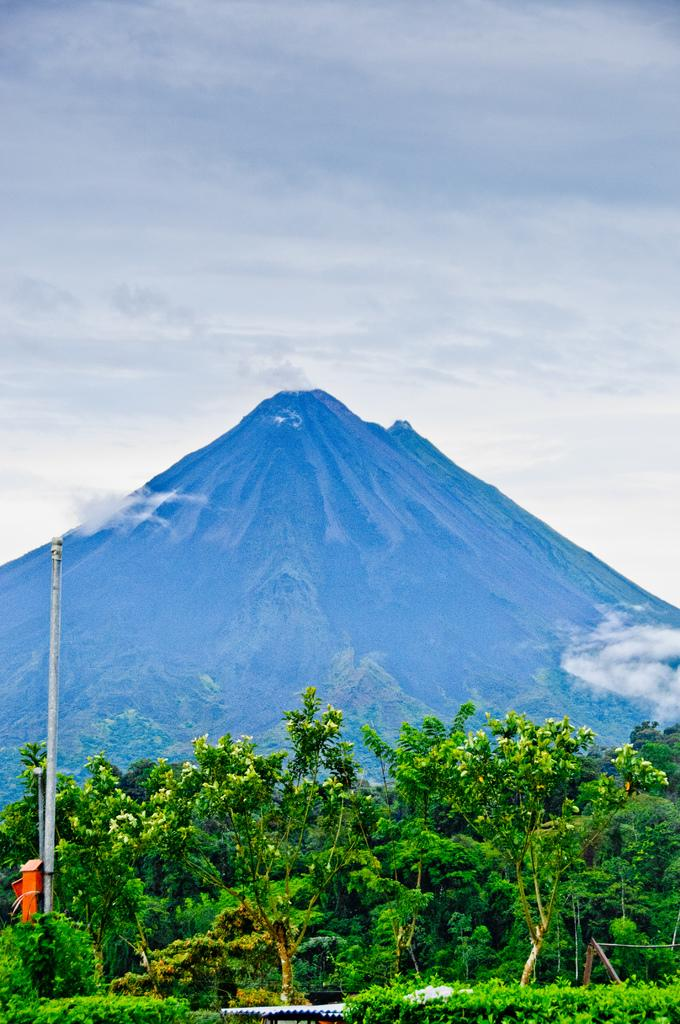What is the main feature of the image? The main feature of the image is the many trees. What can be seen on the left side of the image? There is a pole on the left side of the image. What is visible in the background of the image? Mountains, clouds, and the sky are visible in the background of the image. What year is the balloon scheduled to take off in the image? There is no balloon present in the image, so it is not possible to determine the year of a non-existent event. 